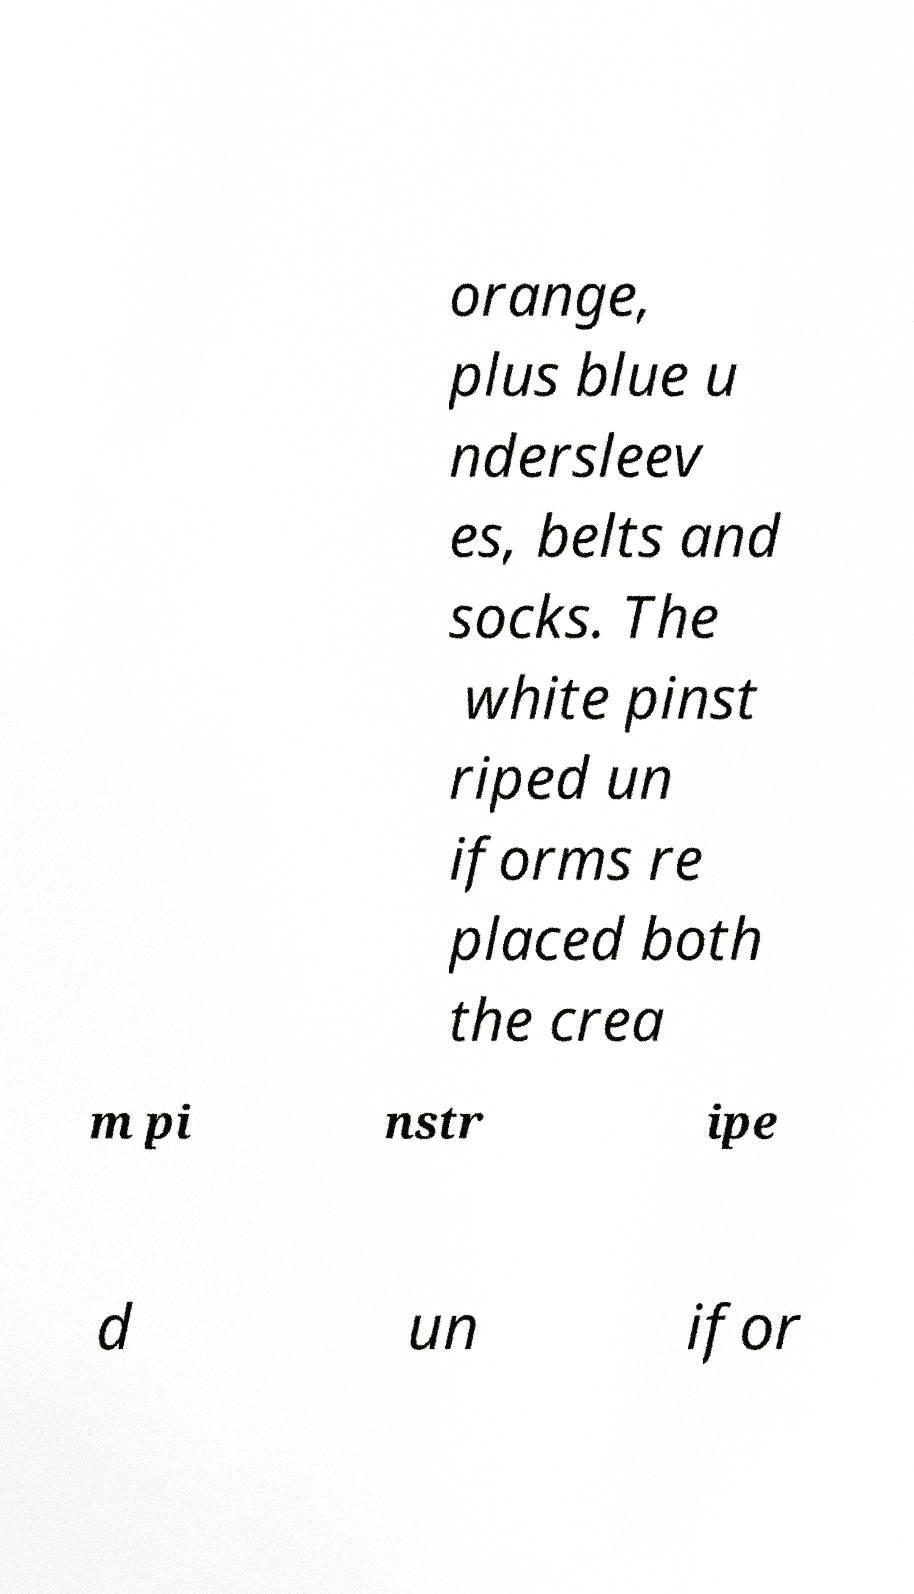I need the written content from this picture converted into text. Can you do that? orange, plus blue u ndersleev es, belts and socks. The white pinst riped un iforms re placed both the crea m pi nstr ipe d un ifor 